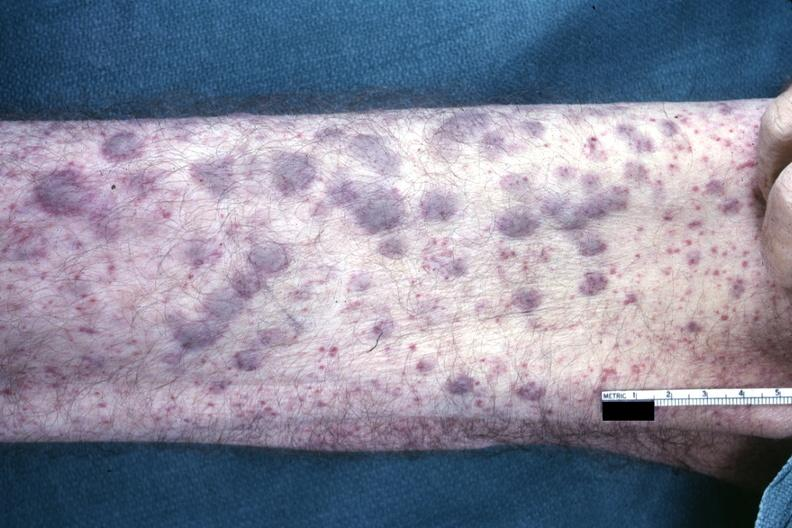what is present?
Answer the question using a single word or phrase. Acute myelogenous leukemia 